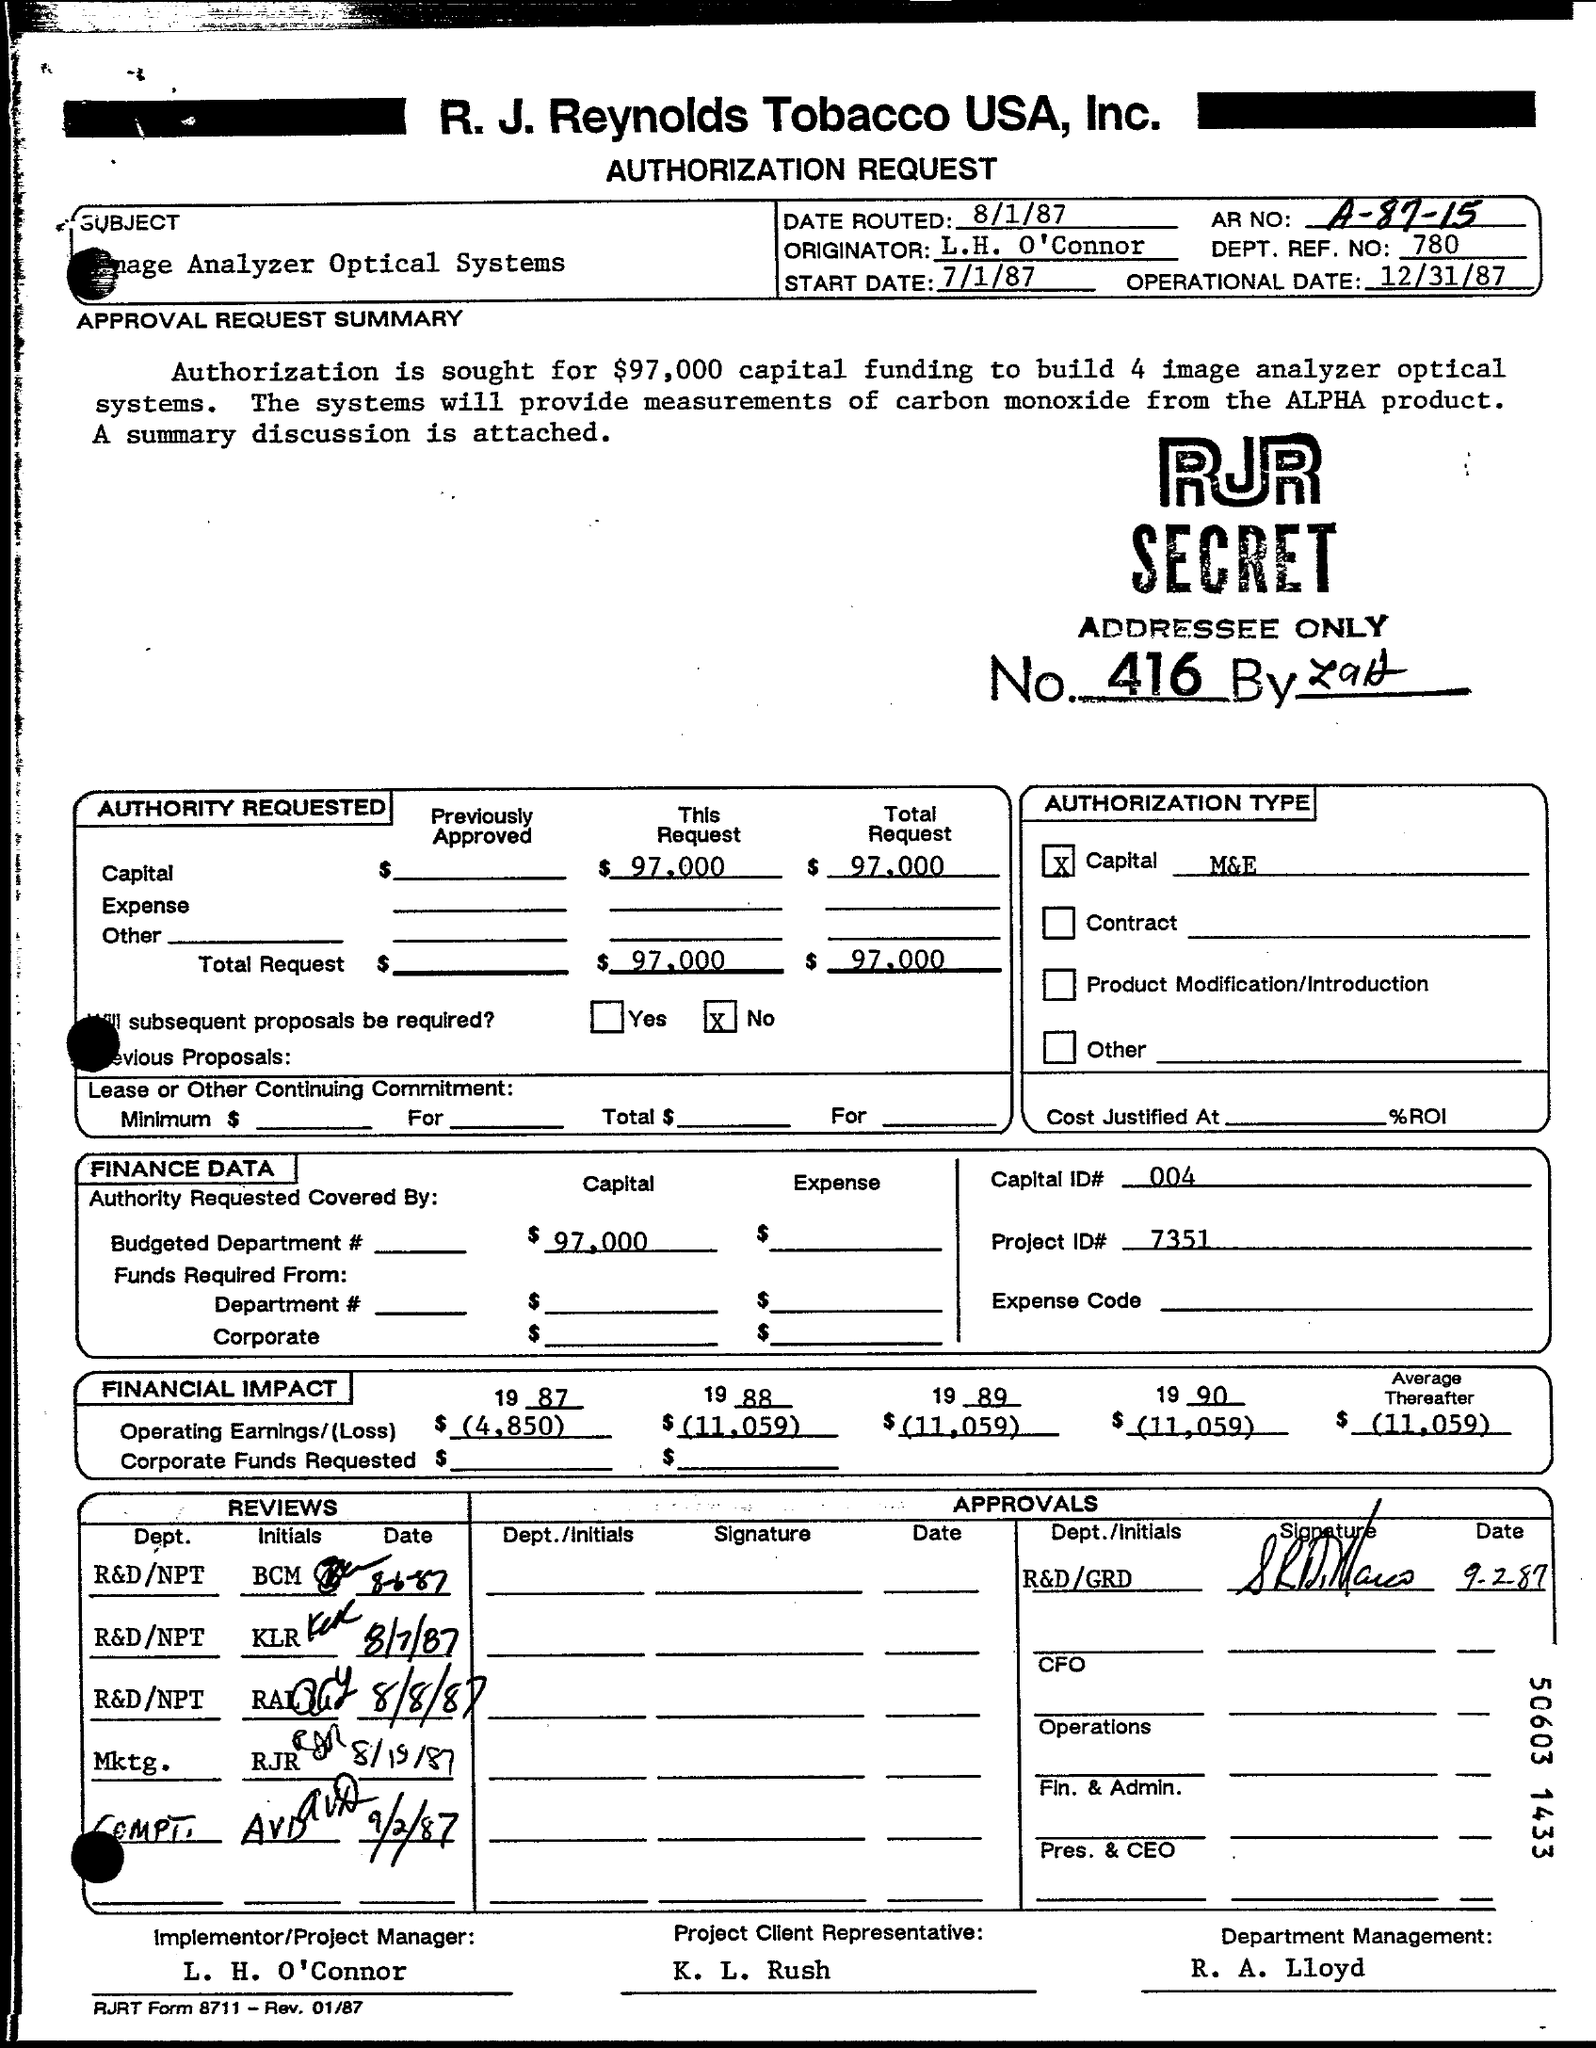Point out several critical features in this image. The operational date is December 31st, 1987. The start date is July 1, 1987. The AR number is A-87-15. Date routed refers to the process of organizing and categorizing a specific date, such as 8/1/87, for the purpose of easy identification and retrieval. 